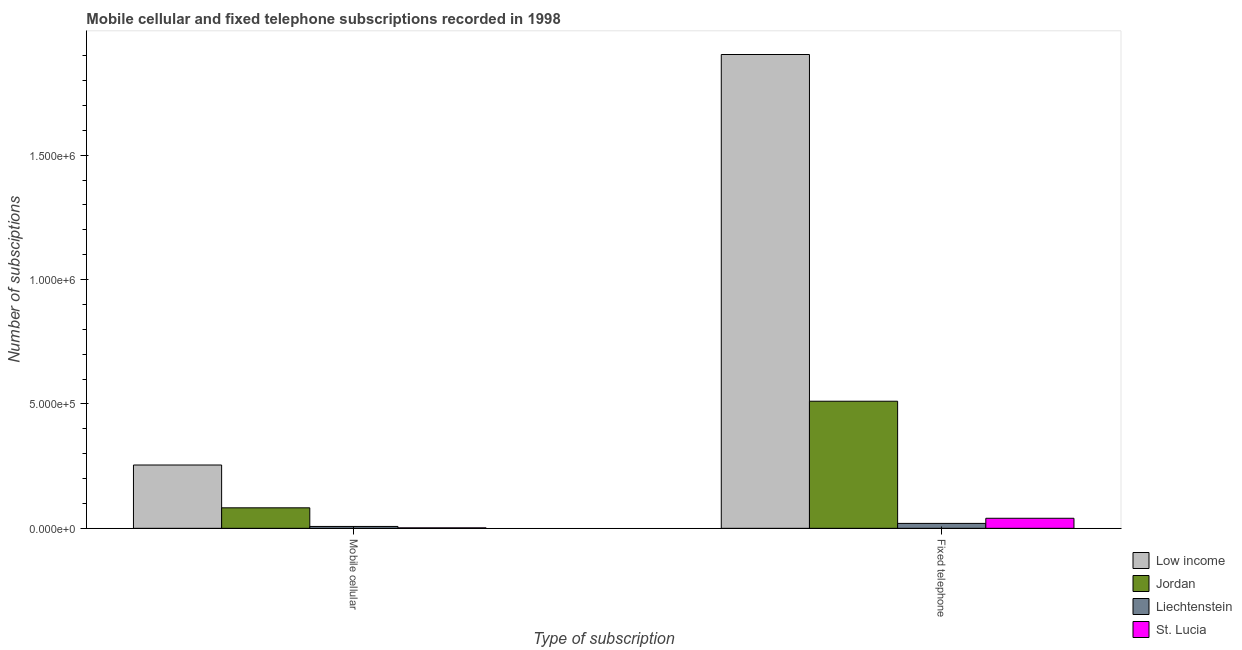How many different coloured bars are there?
Give a very brief answer. 4. Are the number of bars on each tick of the X-axis equal?
Offer a very short reply. Yes. How many bars are there on the 1st tick from the left?
Provide a succinct answer. 4. What is the label of the 1st group of bars from the left?
Give a very brief answer. Mobile cellular. What is the number of fixed telephone subscriptions in Jordan?
Offer a terse response. 5.11e+05. Across all countries, what is the maximum number of mobile cellular subscriptions?
Give a very brief answer. 2.54e+05. Across all countries, what is the minimum number of fixed telephone subscriptions?
Ensure brevity in your answer.  1.98e+04. In which country was the number of mobile cellular subscriptions maximum?
Keep it short and to the point. Low income. In which country was the number of mobile cellular subscriptions minimum?
Your response must be concise. St. Lucia. What is the total number of fixed telephone subscriptions in the graph?
Provide a short and direct response. 2.48e+06. What is the difference between the number of mobile cellular subscriptions in Jordan and that in St. Lucia?
Ensure brevity in your answer.  8.05e+04. What is the difference between the number of fixed telephone subscriptions in St. Lucia and the number of mobile cellular subscriptions in Liechtenstein?
Provide a succinct answer. 3.29e+04. What is the average number of fixed telephone subscriptions per country?
Your response must be concise. 6.19e+05. What is the difference between the number of mobile cellular subscriptions and number of fixed telephone subscriptions in St. Lucia?
Provide a short and direct response. -3.85e+04. What is the ratio of the number of mobile cellular subscriptions in St. Lucia to that in Low income?
Make the answer very short. 0.01. In how many countries, is the number of fixed telephone subscriptions greater than the average number of fixed telephone subscriptions taken over all countries?
Your answer should be compact. 1. What does the 4th bar from the left in Fixed telephone represents?
Your answer should be very brief. St. Lucia. What does the 3rd bar from the right in Mobile cellular represents?
Provide a succinct answer. Jordan. How many bars are there?
Offer a very short reply. 8. How many countries are there in the graph?
Give a very brief answer. 4. What is the difference between two consecutive major ticks on the Y-axis?
Your answer should be compact. 5.00e+05. Are the values on the major ticks of Y-axis written in scientific E-notation?
Your answer should be compact. Yes. Does the graph contain any zero values?
Provide a succinct answer. No. Does the graph contain grids?
Keep it short and to the point. No. How many legend labels are there?
Your answer should be compact. 4. How are the legend labels stacked?
Your answer should be compact. Vertical. What is the title of the graph?
Offer a terse response. Mobile cellular and fixed telephone subscriptions recorded in 1998. Does "China" appear as one of the legend labels in the graph?
Your answer should be very brief. No. What is the label or title of the X-axis?
Give a very brief answer. Type of subscription. What is the label or title of the Y-axis?
Offer a very short reply. Number of subsciptions. What is the Number of subsciptions in Low income in Mobile cellular?
Offer a terse response. 2.54e+05. What is the Number of subsciptions of Jordan in Mobile cellular?
Your response must be concise. 8.24e+04. What is the Number of subsciptions in Liechtenstein in Mobile cellular?
Offer a terse response. 7500. What is the Number of subsciptions of St. Lucia in Mobile cellular?
Provide a short and direct response. 1900. What is the Number of subsciptions in Low income in Fixed telephone?
Your answer should be compact. 1.90e+06. What is the Number of subsciptions of Jordan in Fixed telephone?
Keep it short and to the point. 5.11e+05. What is the Number of subsciptions of Liechtenstein in Fixed telephone?
Give a very brief answer. 1.98e+04. What is the Number of subsciptions of St. Lucia in Fixed telephone?
Provide a short and direct response. 4.04e+04. Across all Type of subscription, what is the maximum Number of subsciptions in Low income?
Your answer should be compact. 1.90e+06. Across all Type of subscription, what is the maximum Number of subsciptions of Jordan?
Provide a short and direct response. 5.11e+05. Across all Type of subscription, what is the maximum Number of subsciptions of Liechtenstein?
Make the answer very short. 1.98e+04. Across all Type of subscription, what is the maximum Number of subsciptions of St. Lucia?
Your answer should be compact. 4.04e+04. Across all Type of subscription, what is the minimum Number of subsciptions in Low income?
Provide a succinct answer. 2.54e+05. Across all Type of subscription, what is the minimum Number of subsciptions of Jordan?
Your answer should be compact. 8.24e+04. Across all Type of subscription, what is the minimum Number of subsciptions in Liechtenstein?
Offer a very short reply. 7500. Across all Type of subscription, what is the minimum Number of subsciptions of St. Lucia?
Give a very brief answer. 1900. What is the total Number of subsciptions in Low income in the graph?
Offer a terse response. 2.16e+06. What is the total Number of subsciptions of Jordan in the graph?
Give a very brief answer. 5.93e+05. What is the total Number of subsciptions in Liechtenstein in the graph?
Make the answer very short. 2.73e+04. What is the total Number of subsciptions in St. Lucia in the graph?
Your answer should be very brief. 4.23e+04. What is the difference between the Number of subsciptions in Low income in Mobile cellular and that in Fixed telephone?
Offer a terse response. -1.65e+06. What is the difference between the Number of subsciptions of Jordan in Mobile cellular and that in Fixed telephone?
Give a very brief answer. -4.28e+05. What is the difference between the Number of subsciptions of Liechtenstein in Mobile cellular and that in Fixed telephone?
Your response must be concise. -1.23e+04. What is the difference between the Number of subsciptions in St. Lucia in Mobile cellular and that in Fixed telephone?
Give a very brief answer. -3.85e+04. What is the difference between the Number of subsciptions of Low income in Mobile cellular and the Number of subsciptions of Jordan in Fixed telephone?
Your response must be concise. -2.56e+05. What is the difference between the Number of subsciptions in Low income in Mobile cellular and the Number of subsciptions in Liechtenstein in Fixed telephone?
Ensure brevity in your answer.  2.35e+05. What is the difference between the Number of subsciptions of Low income in Mobile cellular and the Number of subsciptions of St. Lucia in Fixed telephone?
Your answer should be very brief. 2.14e+05. What is the difference between the Number of subsciptions of Jordan in Mobile cellular and the Number of subsciptions of Liechtenstein in Fixed telephone?
Offer a terse response. 6.27e+04. What is the difference between the Number of subsciptions in Jordan in Mobile cellular and the Number of subsciptions in St. Lucia in Fixed telephone?
Your answer should be very brief. 4.21e+04. What is the difference between the Number of subsciptions of Liechtenstein in Mobile cellular and the Number of subsciptions of St. Lucia in Fixed telephone?
Make the answer very short. -3.29e+04. What is the average Number of subsciptions in Low income per Type of subscription?
Ensure brevity in your answer.  1.08e+06. What is the average Number of subsciptions of Jordan per Type of subscription?
Make the answer very short. 2.97e+05. What is the average Number of subsciptions of Liechtenstein per Type of subscription?
Provide a succinct answer. 1.36e+04. What is the average Number of subsciptions of St. Lucia per Type of subscription?
Provide a short and direct response. 2.11e+04. What is the difference between the Number of subsciptions in Low income and Number of subsciptions in Jordan in Mobile cellular?
Ensure brevity in your answer.  1.72e+05. What is the difference between the Number of subsciptions in Low income and Number of subsciptions in Liechtenstein in Mobile cellular?
Provide a short and direct response. 2.47e+05. What is the difference between the Number of subsciptions in Low income and Number of subsciptions in St. Lucia in Mobile cellular?
Provide a succinct answer. 2.53e+05. What is the difference between the Number of subsciptions in Jordan and Number of subsciptions in Liechtenstein in Mobile cellular?
Ensure brevity in your answer.  7.49e+04. What is the difference between the Number of subsciptions of Jordan and Number of subsciptions of St. Lucia in Mobile cellular?
Offer a very short reply. 8.05e+04. What is the difference between the Number of subsciptions of Liechtenstein and Number of subsciptions of St. Lucia in Mobile cellular?
Ensure brevity in your answer.  5600. What is the difference between the Number of subsciptions in Low income and Number of subsciptions in Jordan in Fixed telephone?
Offer a terse response. 1.39e+06. What is the difference between the Number of subsciptions in Low income and Number of subsciptions in Liechtenstein in Fixed telephone?
Your response must be concise. 1.88e+06. What is the difference between the Number of subsciptions in Low income and Number of subsciptions in St. Lucia in Fixed telephone?
Keep it short and to the point. 1.86e+06. What is the difference between the Number of subsciptions of Jordan and Number of subsciptions of Liechtenstein in Fixed telephone?
Provide a short and direct response. 4.91e+05. What is the difference between the Number of subsciptions in Jordan and Number of subsciptions in St. Lucia in Fixed telephone?
Your response must be concise. 4.71e+05. What is the difference between the Number of subsciptions of Liechtenstein and Number of subsciptions of St. Lucia in Fixed telephone?
Provide a short and direct response. -2.06e+04. What is the ratio of the Number of subsciptions of Low income in Mobile cellular to that in Fixed telephone?
Your answer should be very brief. 0.13. What is the ratio of the Number of subsciptions of Jordan in Mobile cellular to that in Fixed telephone?
Your response must be concise. 0.16. What is the ratio of the Number of subsciptions in Liechtenstein in Mobile cellular to that in Fixed telephone?
Make the answer very short. 0.38. What is the ratio of the Number of subsciptions of St. Lucia in Mobile cellular to that in Fixed telephone?
Offer a terse response. 0.05. What is the difference between the highest and the second highest Number of subsciptions of Low income?
Offer a terse response. 1.65e+06. What is the difference between the highest and the second highest Number of subsciptions in Jordan?
Offer a terse response. 4.28e+05. What is the difference between the highest and the second highest Number of subsciptions in Liechtenstein?
Give a very brief answer. 1.23e+04. What is the difference between the highest and the second highest Number of subsciptions of St. Lucia?
Ensure brevity in your answer.  3.85e+04. What is the difference between the highest and the lowest Number of subsciptions of Low income?
Offer a terse response. 1.65e+06. What is the difference between the highest and the lowest Number of subsciptions of Jordan?
Provide a short and direct response. 4.28e+05. What is the difference between the highest and the lowest Number of subsciptions of Liechtenstein?
Your answer should be compact. 1.23e+04. What is the difference between the highest and the lowest Number of subsciptions in St. Lucia?
Your answer should be very brief. 3.85e+04. 